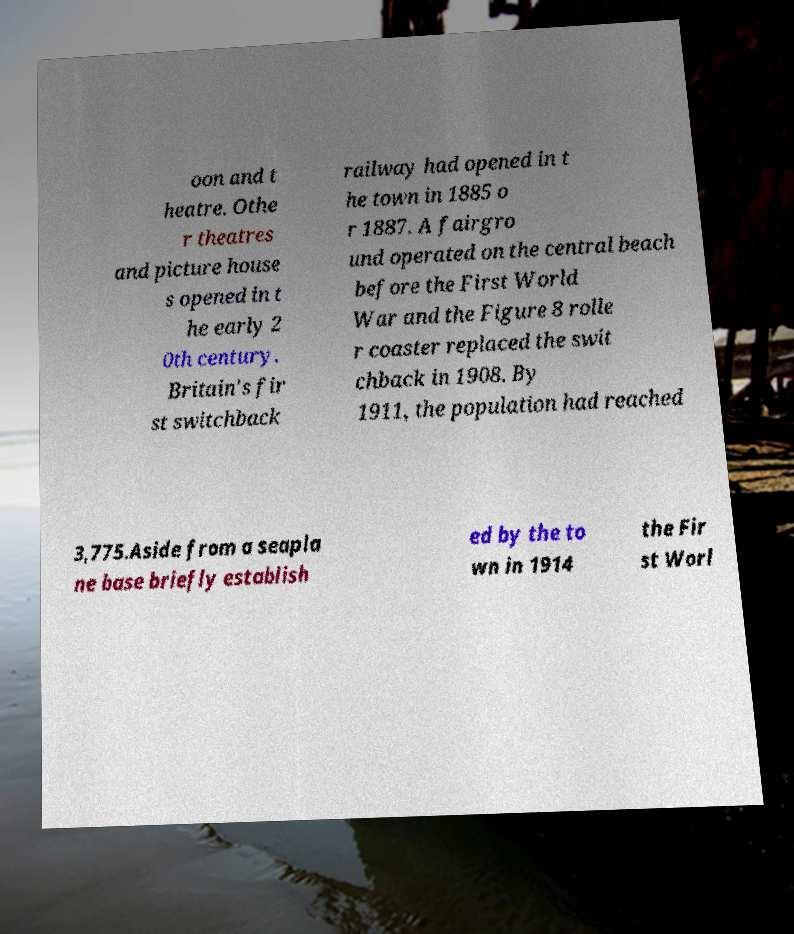There's text embedded in this image that I need extracted. Can you transcribe it verbatim? oon and t heatre. Othe r theatres and picture house s opened in t he early 2 0th century. Britain's fir st switchback railway had opened in t he town in 1885 o r 1887. A fairgro und operated on the central beach before the First World War and the Figure 8 rolle r coaster replaced the swit chback in 1908. By 1911, the population had reached 3,775.Aside from a seapla ne base briefly establish ed by the to wn in 1914 the Fir st Worl 